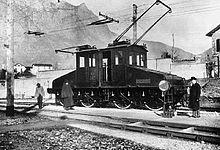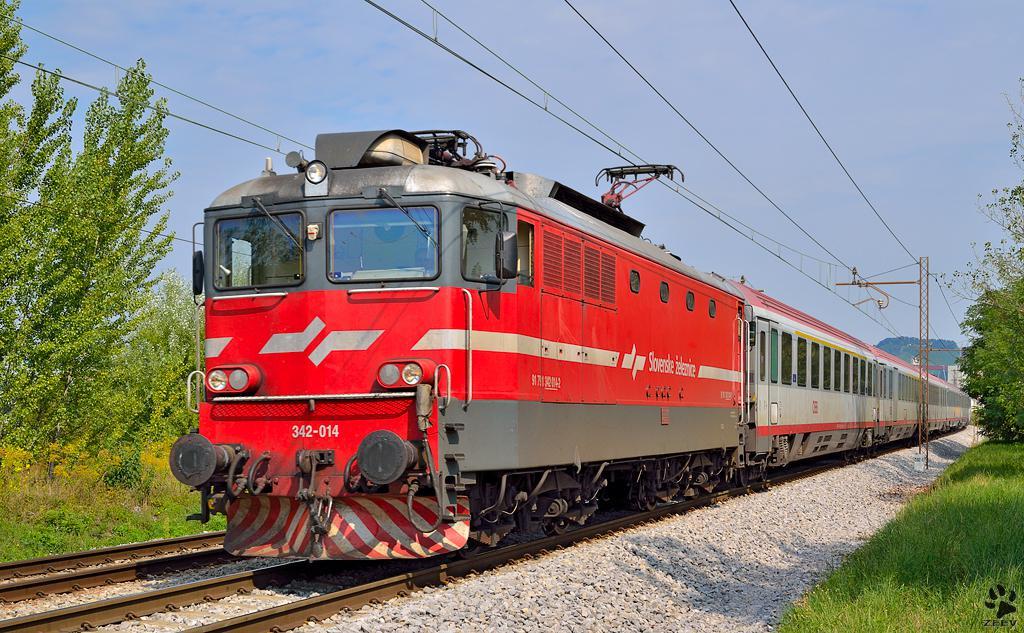The first image is the image on the left, the second image is the image on the right. Analyze the images presented: Is the assertion "Exactly two locomotives are different colors and have different window designs, but are both headed in the same general direction and pulling a line of train cars." valid? Answer yes or no. No. 